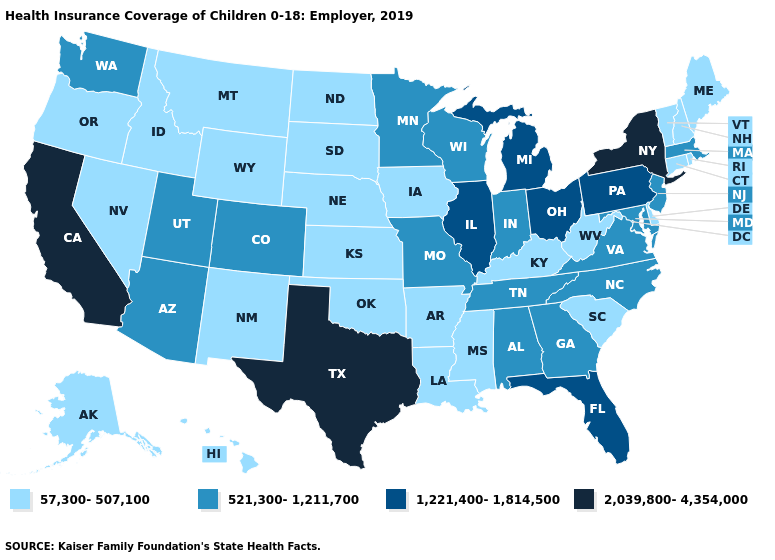Does California have the highest value in the USA?
Be succinct. Yes. Which states have the lowest value in the USA?
Quick response, please. Alaska, Arkansas, Connecticut, Delaware, Hawaii, Idaho, Iowa, Kansas, Kentucky, Louisiana, Maine, Mississippi, Montana, Nebraska, Nevada, New Hampshire, New Mexico, North Dakota, Oklahoma, Oregon, Rhode Island, South Carolina, South Dakota, Vermont, West Virginia, Wyoming. Does South Dakota have the highest value in the USA?
Be succinct. No. Which states have the highest value in the USA?
Give a very brief answer. California, New York, Texas. Name the states that have a value in the range 1,221,400-1,814,500?
Answer briefly. Florida, Illinois, Michigan, Ohio, Pennsylvania. What is the lowest value in the USA?
Quick response, please. 57,300-507,100. What is the highest value in states that border Florida?
Short answer required. 521,300-1,211,700. Does the first symbol in the legend represent the smallest category?
Answer briefly. Yes. What is the value of Illinois?
Quick response, please. 1,221,400-1,814,500. Among the states that border New Hampshire , which have the lowest value?
Be succinct. Maine, Vermont. What is the value of Ohio?
Write a very short answer. 1,221,400-1,814,500. Which states have the lowest value in the USA?
Give a very brief answer. Alaska, Arkansas, Connecticut, Delaware, Hawaii, Idaho, Iowa, Kansas, Kentucky, Louisiana, Maine, Mississippi, Montana, Nebraska, Nevada, New Hampshire, New Mexico, North Dakota, Oklahoma, Oregon, Rhode Island, South Carolina, South Dakota, Vermont, West Virginia, Wyoming. Which states have the lowest value in the Northeast?
Concise answer only. Connecticut, Maine, New Hampshire, Rhode Island, Vermont. Name the states that have a value in the range 2,039,800-4,354,000?
Concise answer only. California, New York, Texas. Does the map have missing data?
Keep it brief. No. 